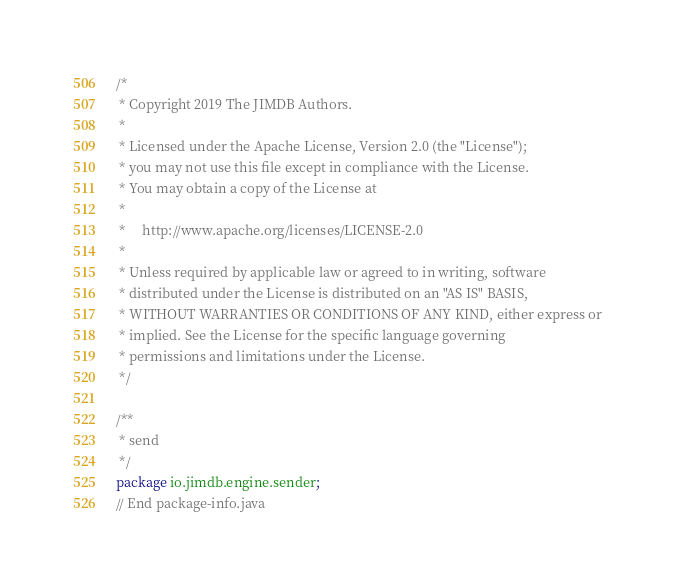Convert code to text. <code><loc_0><loc_0><loc_500><loc_500><_Java_>/*
 * Copyright 2019 The JIMDB Authors.
 *
 * Licensed under the Apache License, Version 2.0 (the "License");
 * you may not use this file except in compliance with the License.
 * You may obtain a copy of the License at
 *
 *     http://www.apache.org/licenses/LICENSE-2.0
 *
 * Unless required by applicable law or agreed to in writing, software
 * distributed under the License is distributed on an "AS IS" BASIS,
 * WITHOUT WARRANTIES OR CONDITIONS OF ANY KIND, either express or
 * implied. See the License for the specific language governing
 * permissions and limitations under the License.
 */

/**
 * send
 */
package io.jimdb.engine.sender;
// End package-info.java
</code> 